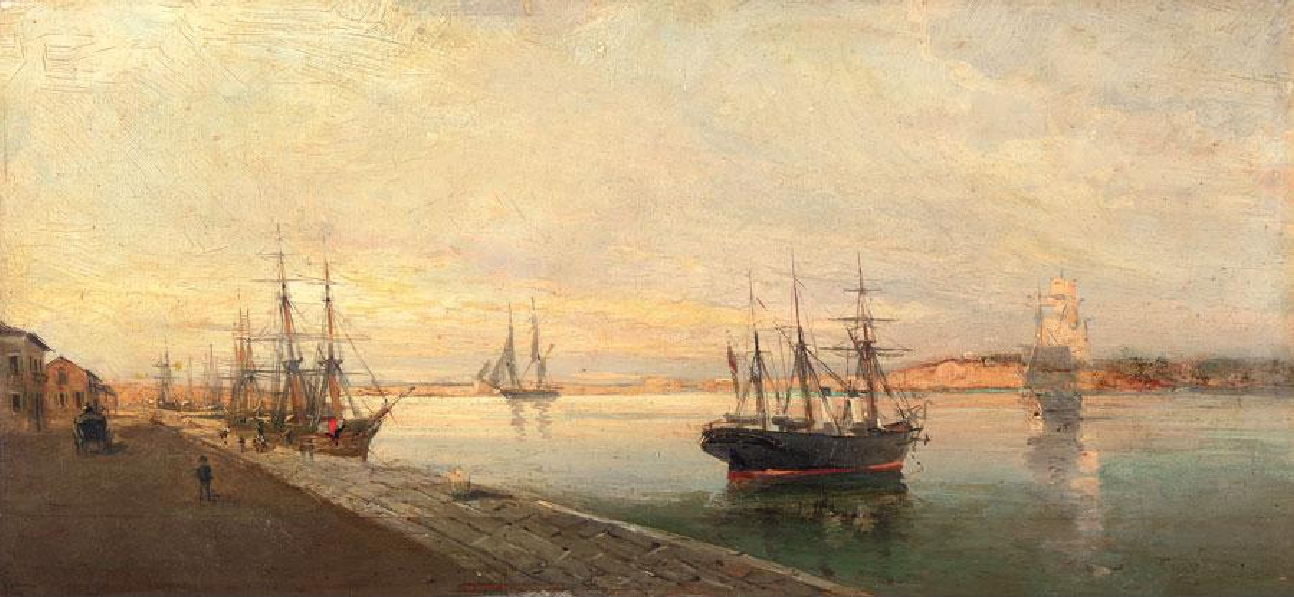What emotions do you think the artist was trying to convey? The artist likely aimed to evoke a sense of tranquility and warmth through the choice of warm hues and serene setting. The gentle light and calm waters suggest a peaceful, reflective mood, while the presence of ships and human activity conveys a sense of everyday life and industriousness. This combination of calmness and activity can make the viewer feel both relaxed and engaged. 